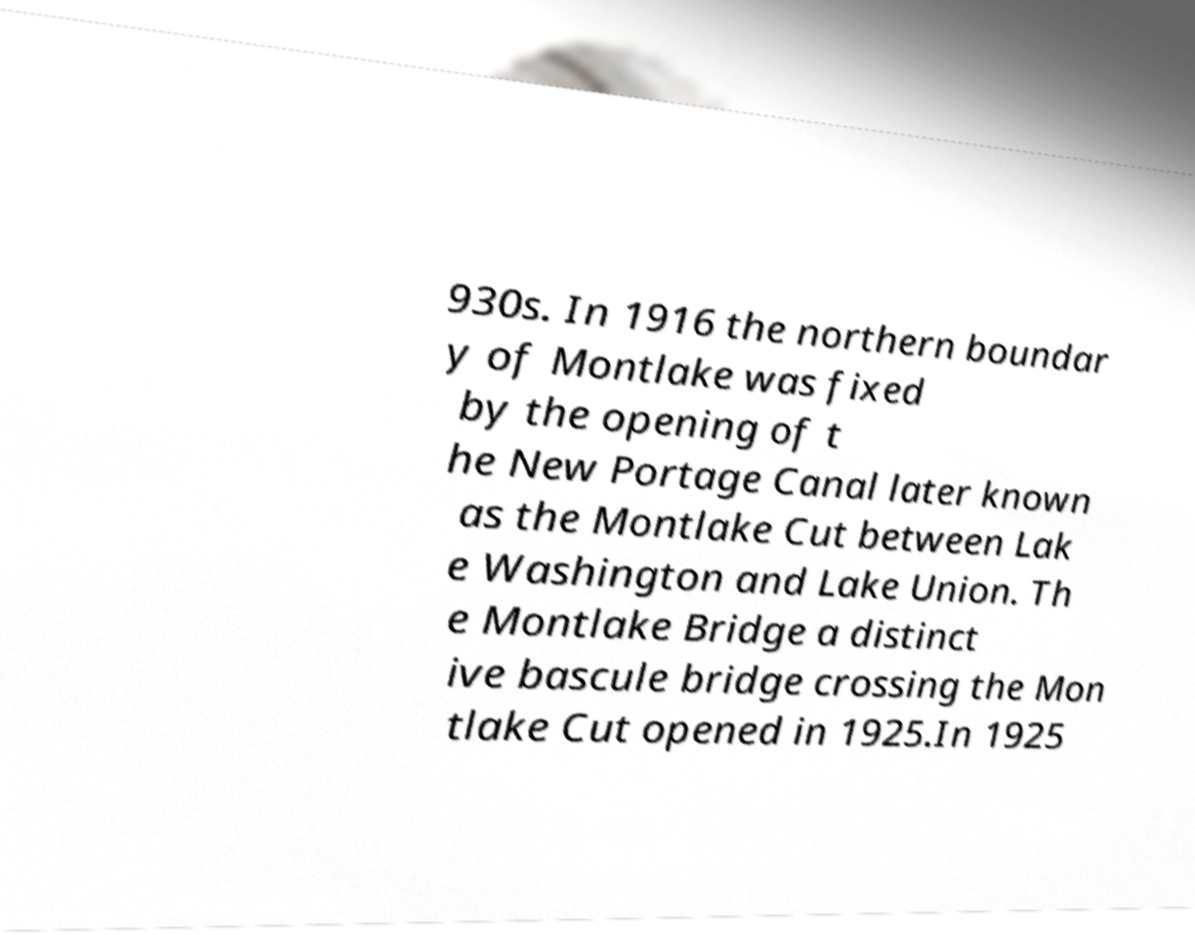Can you accurately transcribe the text from the provided image for me? 930s. In 1916 the northern boundar y of Montlake was fixed by the opening of t he New Portage Canal later known as the Montlake Cut between Lak e Washington and Lake Union. Th e Montlake Bridge a distinct ive bascule bridge crossing the Mon tlake Cut opened in 1925.In 1925 